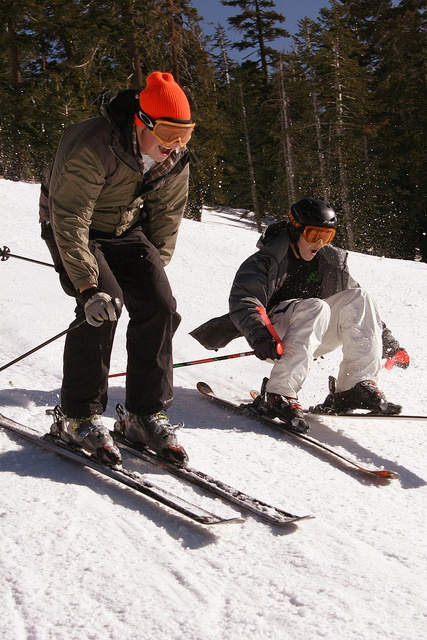Describe the objects in this image and their specific colors. I can see people in black, maroon, and gray tones, people in black, darkgray, lightgray, and gray tones, skis in black, lightgray, gray, and darkgray tones, and skis in black, gray, maroon, and lightgray tones in this image. 